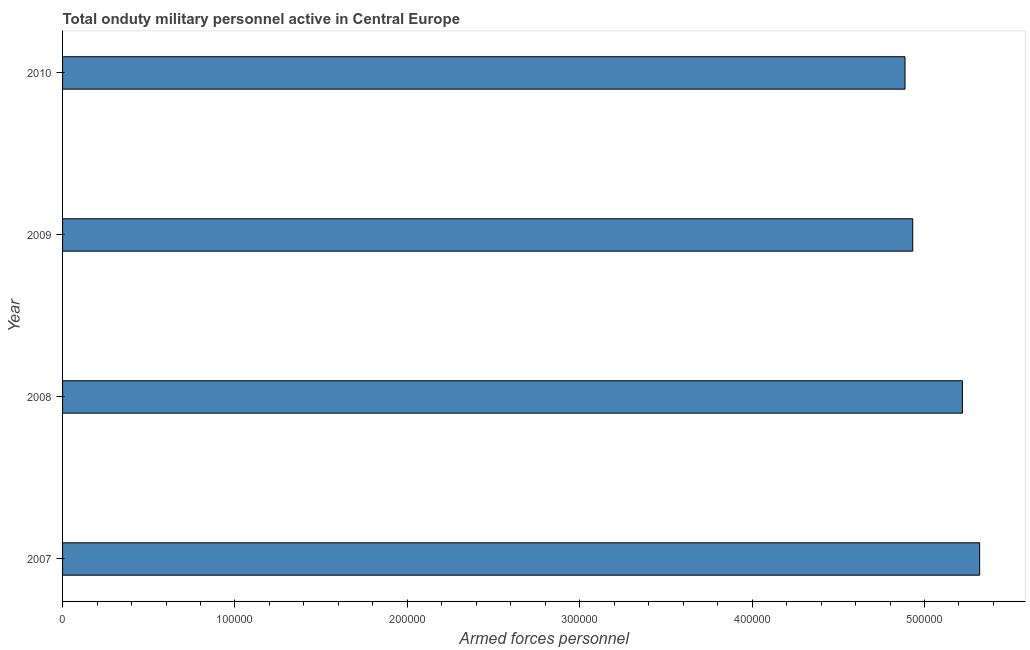Does the graph contain grids?
Your answer should be very brief. No. What is the title of the graph?
Your response must be concise. Total onduty military personnel active in Central Europe. What is the label or title of the X-axis?
Your response must be concise. Armed forces personnel. What is the number of armed forces personnel in 2007?
Ensure brevity in your answer.  5.32e+05. Across all years, what is the maximum number of armed forces personnel?
Your answer should be very brief. 5.32e+05. Across all years, what is the minimum number of armed forces personnel?
Your answer should be compact. 4.89e+05. In which year was the number of armed forces personnel minimum?
Offer a terse response. 2010. What is the sum of the number of armed forces personnel?
Ensure brevity in your answer.  2.04e+06. What is the difference between the number of armed forces personnel in 2007 and 2009?
Your response must be concise. 3.88e+04. What is the average number of armed forces personnel per year?
Your answer should be compact. 5.09e+05. What is the median number of armed forces personnel?
Your answer should be very brief. 5.08e+05. In how many years, is the number of armed forces personnel greater than 240000 ?
Offer a terse response. 4. Do a majority of the years between 2009 and 2007 (inclusive) have number of armed forces personnel greater than 40000 ?
Provide a succinct answer. Yes. Is the difference between the number of armed forces personnel in 2007 and 2010 greater than the difference between any two years?
Provide a short and direct response. Yes. What is the difference between the highest and the second highest number of armed forces personnel?
Your response must be concise. 10000. Is the sum of the number of armed forces personnel in 2008 and 2009 greater than the maximum number of armed forces personnel across all years?
Offer a terse response. Yes. What is the difference between the highest and the lowest number of armed forces personnel?
Provide a succinct answer. 4.33e+04. Are all the bars in the graph horizontal?
Your answer should be compact. Yes. What is the difference between two consecutive major ticks on the X-axis?
Offer a terse response. 1.00e+05. Are the values on the major ticks of X-axis written in scientific E-notation?
Make the answer very short. No. What is the Armed forces personnel in 2007?
Your answer should be compact. 5.32e+05. What is the Armed forces personnel in 2008?
Provide a short and direct response. 5.22e+05. What is the Armed forces personnel of 2009?
Give a very brief answer. 4.93e+05. What is the Armed forces personnel of 2010?
Keep it short and to the point. 4.89e+05. What is the difference between the Armed forces personnel in 2007 and 2009?
Your response must be concise. 3.88e+04. What is the difference between the Armed forces personnel in 2007 and 2010?
Keep it short and to the point. 4.33e+04. What is the difference between the Armed forces personnel in 2008 and 2009?
Ensure brevity in your answer.  2.88e+04. What is the difference between the Armed forces personnel in 2008 and 2010?
Your answer should be compact. 3.33e+04. What is the difference between the Armed forces personnel in 2009 and 2010?
Your answer should be very brief. 4481. What is the ratio of the Armed forces personnel in 2007 to that in 2008?
Provide a succinct answer. 1.02. What is the ratio of the Armed forces personnel in 2007 to that in 2009?
Your answer should be compact. 1.08. What is the ratio of the Armed forces personnel in 2007 to that in 2010?
Ensure brevity in your answer.  1.09. What is the ratio of the Armed forces personnel in 2008 to that in 2009?
Your answer should be very brief. 1.06. What is the ratio of the Armed forces personnel in 2008 to that in 2010?
Offer a very short reply. 1.07. 